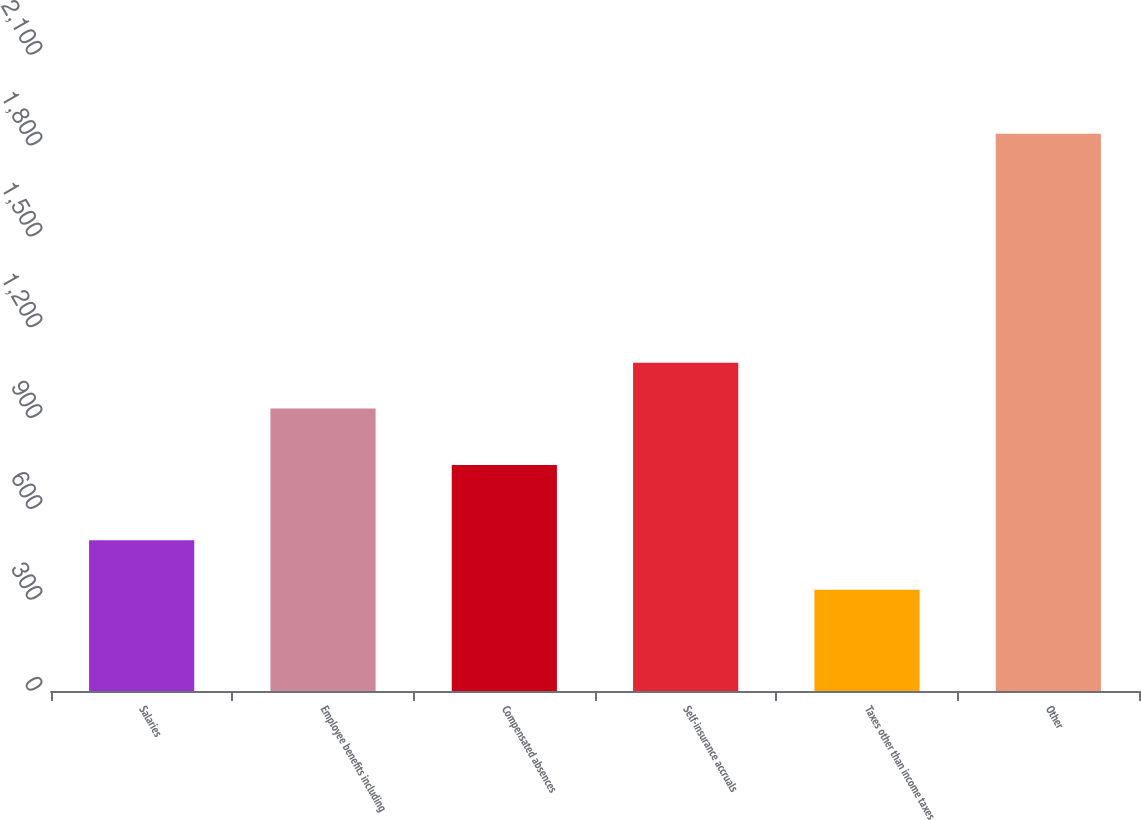Convert chart. <chart><loc_0><loc_0><loc_500><loc_500><bar_chart><fcel>Salaries<fcel>Employee benefits including<fcel>Compensated absences<fcel>Self-insurance accruals<fcel>Taxes other than income taxes<fcel>Other<nl><fcel>498<fcel>933<fcel>746<fcel>1083.6<fcel>334<fcel>1840<nl></chart> 